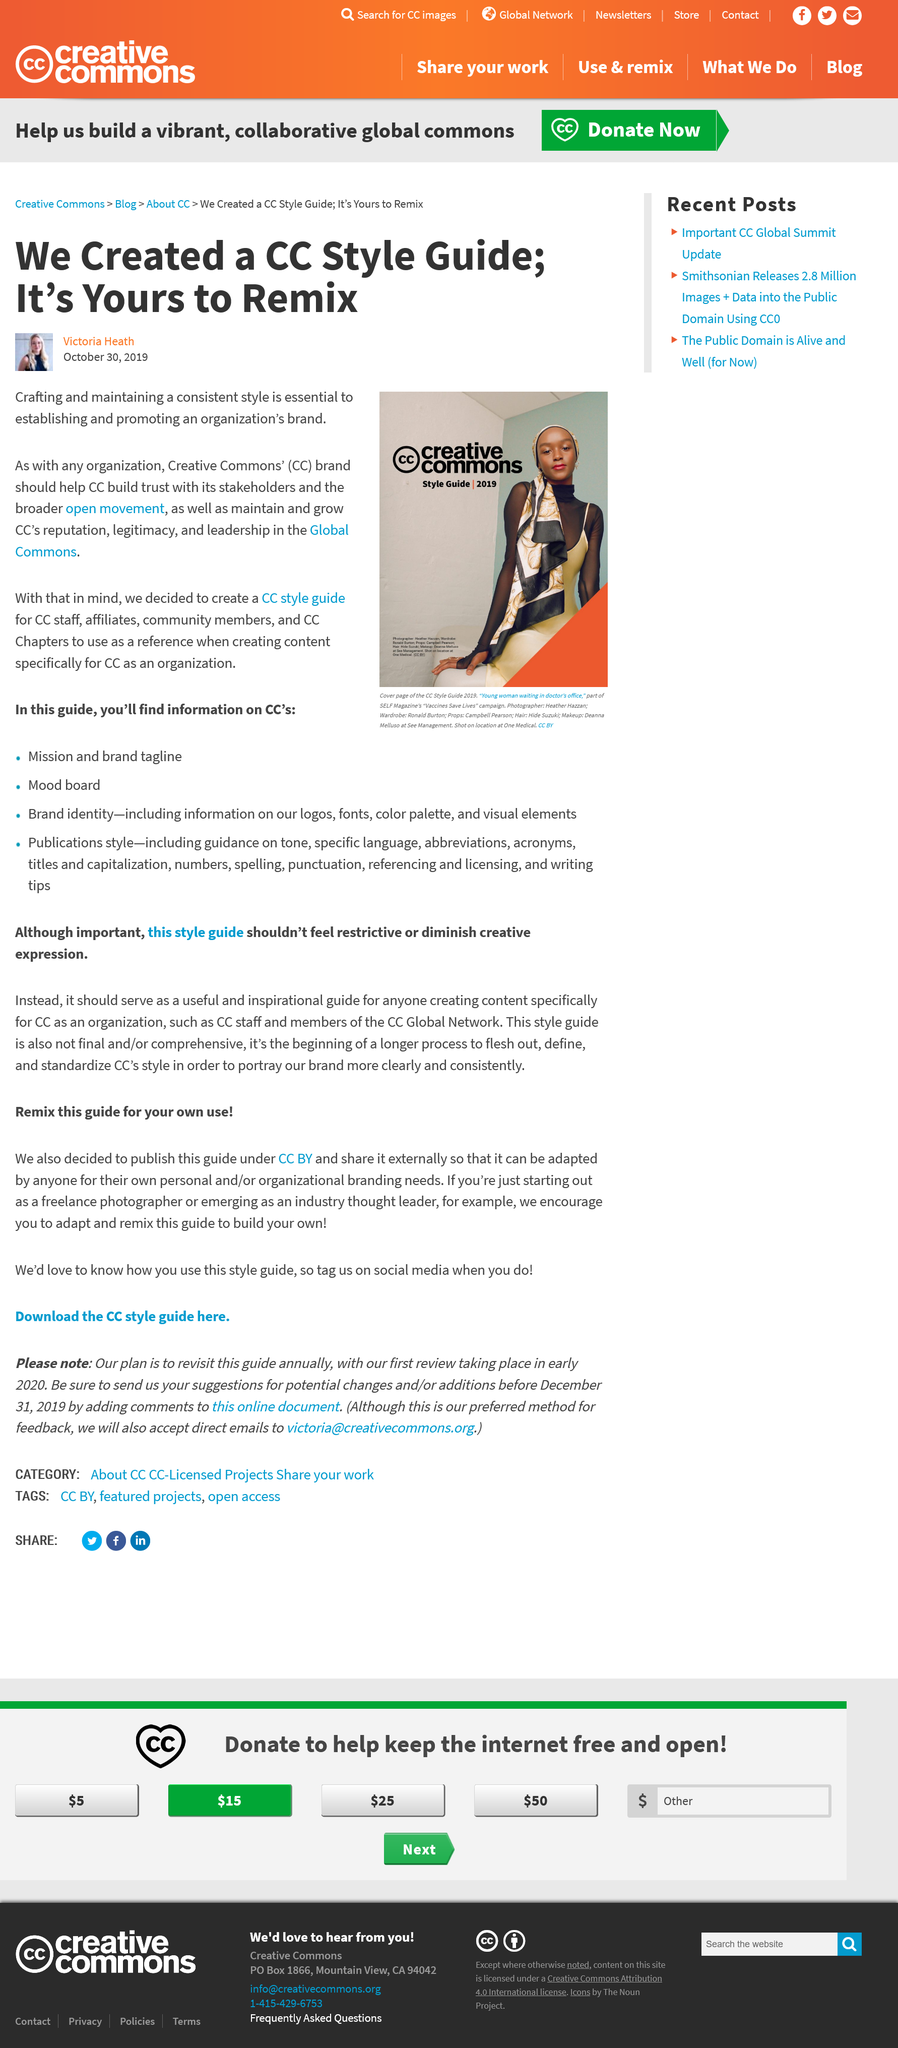Highlight a few significant elements in this photo. In the year 2019, the image was taken. In the image, the title is referred to as Creative Commons. We have created a CC Styke Guide that is now available for remixing. 